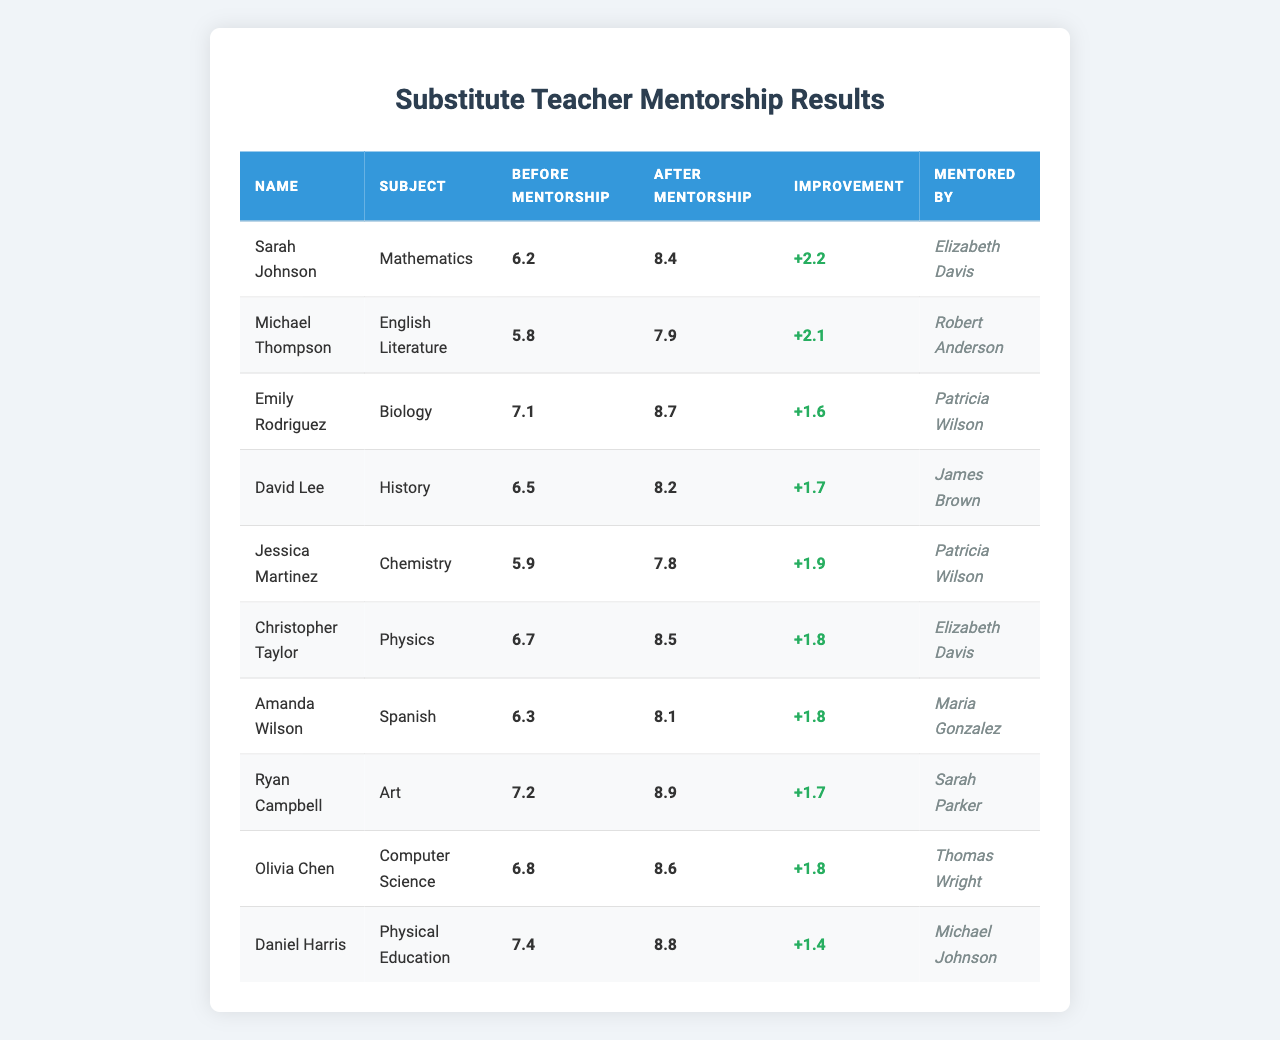What was the highest after-mentorship score? Examining the "After Mentorship" column, the highest score is 8.9, attributed to Ryan Campbell in Art.
Answer: 8.9 Who had the least improvement in scores? By comparing the "Improvement" column, Jessica Martinez had the smallest increase of +1.9.
Answer: Jessica Martinez What is the average before-mentorship score? Adding the before-mentorship scores (6.2 + 5.8 + 7.1 + 6.5 + 5.9 + 6.7 + 6.3 + 7.2 + 6.8 + 7.4) gives a total of 66.8. Dividing by 10 (the number of teachers) results in an average of 6.68.
Answer: 6.68 Did Emily Rodriguez receive mentorship from Patricia Wilson? Checking the "Mentored By" column, it shows that Emily Rodriguez was indeed mentored by Patricia Wilson.
Answer: Yes What is the total improvement in scores for all substitute teachers combined? The individual improvements are: 2.2, 2.1, 1.6, 1.7, 1.9, 1.8, 1.8, 1.7, 1.8, and 1.4. Adding these values gives a total improvement of 18.4.
Answer: 18.4 Which subject had the highest before-mentorship score? Observing the "Before Mentorship" column shows that Physical Education, taught by Daniel Harris, has the highest score at 7.4.
Answer: Physical Education How many teachers improved their scores by more than 2 points? Reviewing the "Improvement" column, the teachers Sarah Johnson, Michael Thompson, Emily Rodriguez, David Lee, and Ryan Campbell all improved by more than 2 points, totaling 5 teachers.
Answer: 5 What is the median after-mentorship score? Sorting the after-mentorship scores (7.8, 8.1, 8.2, 8.4, 8.5, 8.6, 8.7, 8.8, 8.9) and finding the middle value, the median score is 8.4.
Answer: 8.4 Did Amanda Wilson achieve a score above 8 after mentorship? Checking Amanda Wilson's after-mentorship score reveals it to be 8.1, which is below 8.
Answer: No What is the difference between the highest and lowest before-mentorship scores? The highest before-mentorship score is 7.4 (Daniel Harris) and the lowest is 5.8 (Michael Thompson). The difference is 7.4 - 5.8 = 1.6.
Answer: 1.6 How many mentors are represented in the table? The mentors listed are Elizabeth Davis, Robert Anderson, Patricia Wilson, James Brown, Maria Gonzalez, Sarah Parker, and Thomas Wright. This makes a total of 7 unique mentors.
Answer: 7 